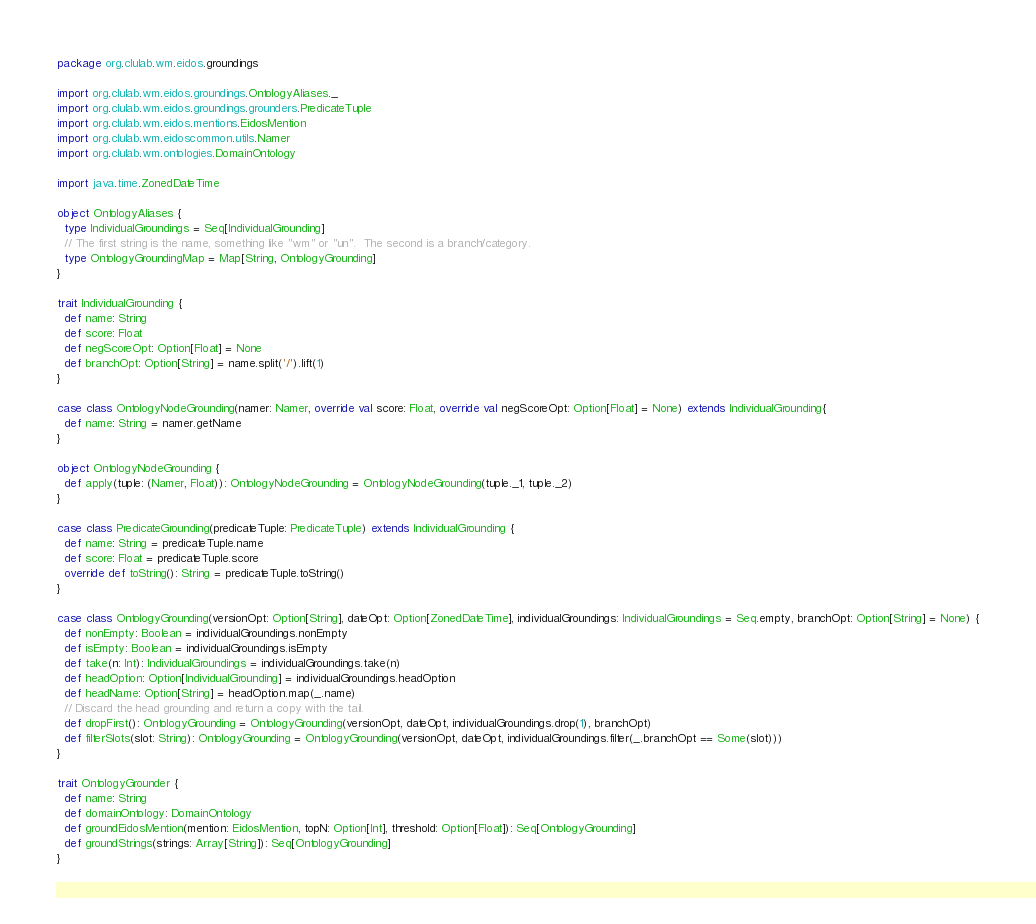Convert code to text. <code><loc_0><loc_0><loc_500><loc_500><_Scala_>package org.clulab.wm.eidos.groundings

import org.clulab.wm.eidos.groundings.OntologyAliases._
import org.clulab.wm.eidos.groundings.grounders.PredicateTuple
import org.clulab.wm.eidos.mentions.EidosMention
import org.clulab.wm.eidoscommon.utils.Namer
import org.clulab.wm.ontologies.DomainOntology

import java.time.ZonedDateTime

object OntologyAliases {
  type IndividualGroundings = Seq[IndividualGrounding]
  // The first string is the name, something like "wm" or "un".  The second is a branch/category.
  type OntologyGroundingMap = Map[String, OntologyGrounding]
}

trait IndividualGrounding {
  def name: String
  def score: Float
  def negScoreOpt: Option[Float] = None
  def branchOpt: Option[String] = name.split('/').lift(1)
}

case class OntologyNodeGrounding(namer: Namer, override val score: Float, override val negScoreOpt: Option[Float] = None) extends IndividualGrounding{
  def name: String = namer.getName
}

object OntologyNodeGrounding {
  def apply(tuple: (Namer, Float)): OntologyNodeGrounding = OntologyNodeGrounding(tuple._1, tuple._2)
}

case class PredicateGrounding(predicateTuple: PredicateTuple) extends IndividualGrounding {
  def name: String = predicateTuple.name
  def score: Float = predicateTuple.score
  override def toString(): String = predicateTuple.toString()
}

case class OntologyGrounding(versionOpt: Option[String], dateOpt: Option[ZonedDateTime], individualGroundings: IndividualGroundings = Seq.empty, branchOpt: Option[String] = None) {
  def nonEmpty: Boolean = individualGroundings.nonEmpty
  def isEmpty: Boolean = individualGroundings.isEmpty
  def take(n: Int): IndividualGroundings = individualGroundings.take(n)
  def headOption: Option[IndividualGrounding] = individualGroundings.headOption
  def headName: Option[String] = headOption.map(_.name)
  // Discard the head grounding and return a copy with the tail.
  def dropFirst(): OntologyGrounding = OntologyGrounding(versionOpt, dateOpt, individualGroundings.drop(1), branchOpt)
  def filterSlots(slot: String): OntologyGrounding = OntologyGrounding(versionOpt, dateOpt, individualGroundings.filter(_.branchOpt == Some(slot)))
}

trait OntologyGrounder {
  def name: String
  def domainOntology: DomainOntology
  def groundEidosMention(mention: EidosMention, topN: Option[Int], threshold: Option[Float]): Seq[OntologyGrounding]
  def groundStrings(strings: Array[String]): Seq[OntologyGrounding]
}
</code> 